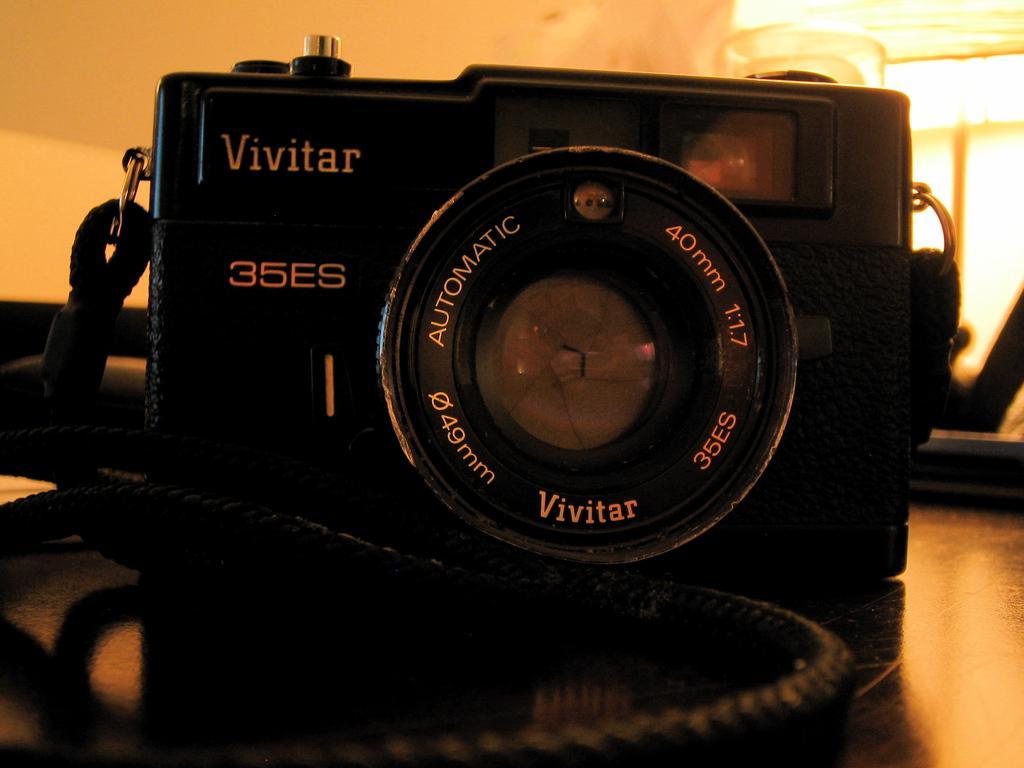Describe this image in one or two sentences. This image consists of a camera. It is in black color. There are lights at the top. 